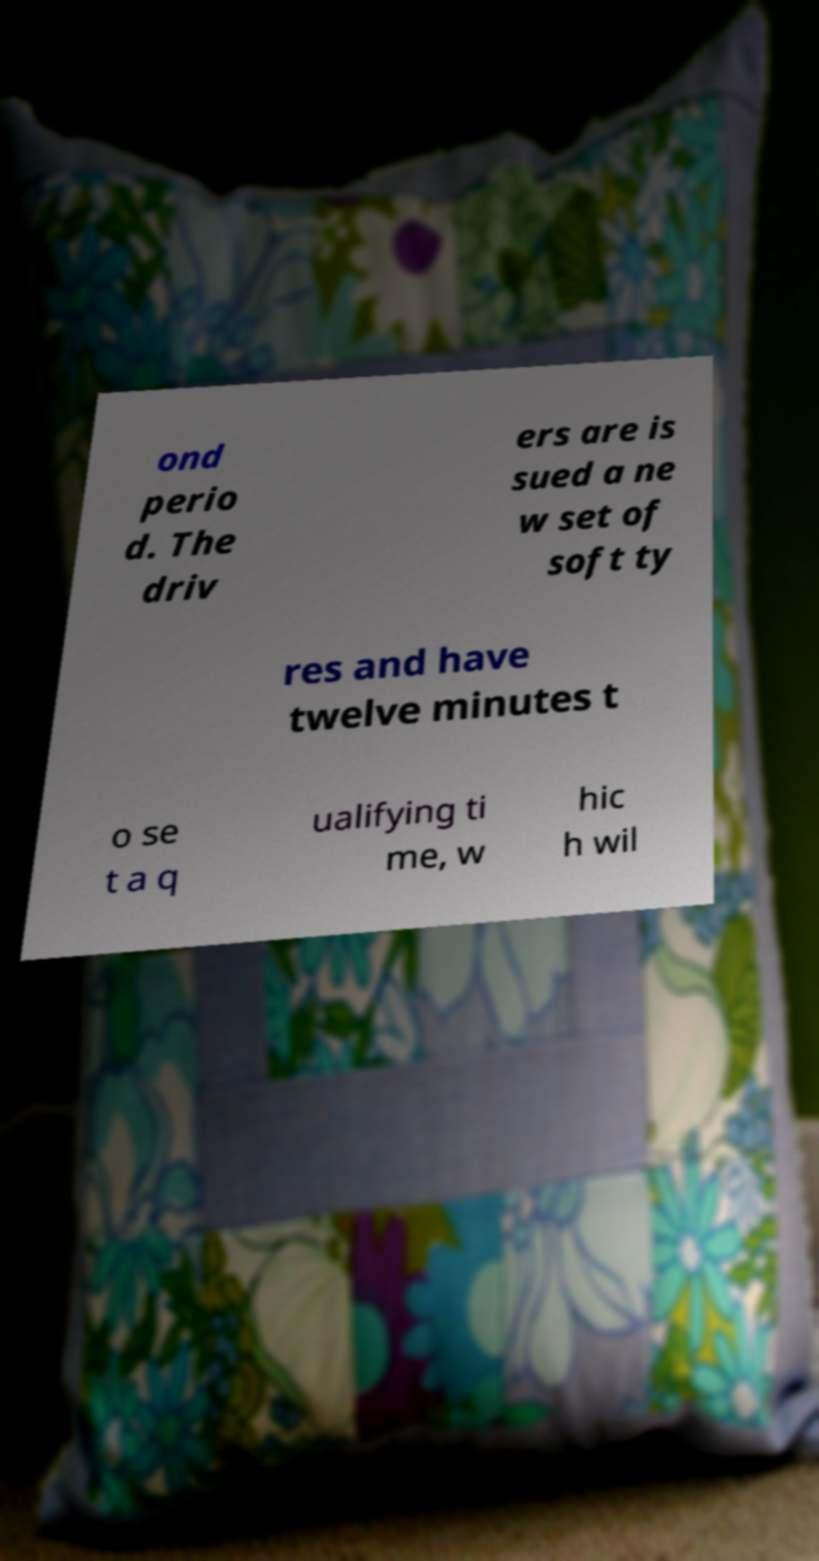Can you read and provide the text displayed in the image?This photo seems to have some interesting text. Can you extract and type it out for me? ond perio d. The driv ers are is sued a ne w set of soft ty res and have twelve minutes t o se t a q ualifying ti me, w hic h wil 